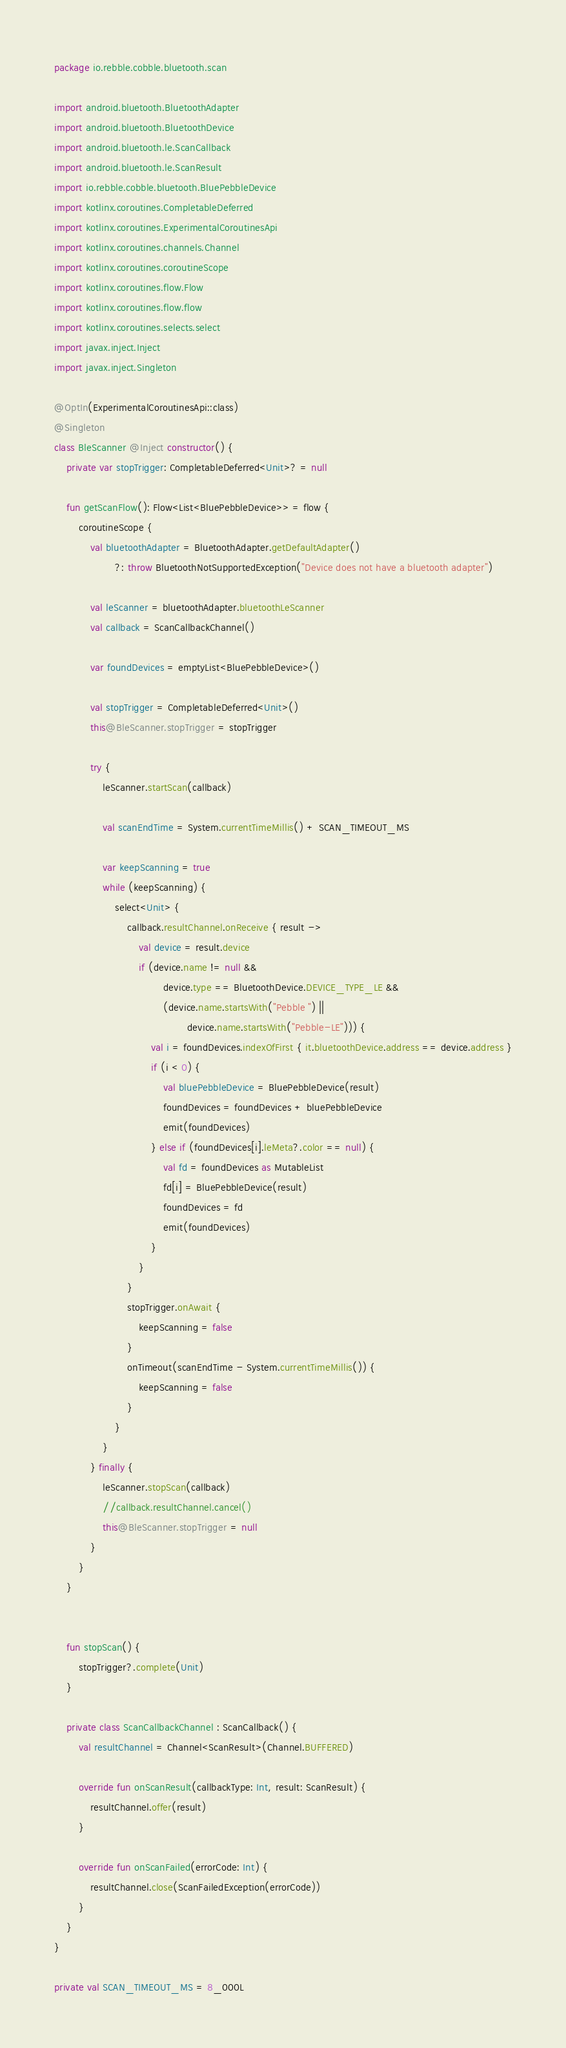Convert code to text. <code><loc_0><loc_0><loc_500><loc_500><_Kotlin_>package io.rebble.cobble.bluetooth.scan

import android.bluetooth.BluetoothAdapter
import android.bluetooth.BluetoothDevice
import android.bluetooth.le.ScanCallback
import android.bluetooth.le.ScanResult
import io.rebble.cobble.bluetooth.BluePebbleDevice
import kotlinx.coroutines.CompletableDeferred
import kotlinx.coroutines.ExperimentalCoroutinesApi
import kotlinx.coroutines.channels.Channel
import kotlinx.coroutines.coroutineScope
import kotlinx.coroutines.flow.Flow
import kotlinx.coroutines.flow.flow
import kotlinx.coroutines.selects.select
import javax.inject.Inject
import javax.inject.Singleton

@OptIn(ExperimentalCoroutinesApi::class)
@Singleton
class BleScanner @Inject constructor() {
    private var stopTrigger: CompletableDeferred<Unit>? = null

    fun getScanFlow(): Flow<List<BluePebbleDevice>> = flow {
        coroutineScope {
            val bluetoothAdapter = BluetoothAdapter.getDefaultAdapter()
                    ?: throw BluetoothNotSupportedException("Device does not have a bluetooth adapter")

            val leScanner = bluetoothAdapter.bluetoothLeScanner
            val callback = ScanCallbackChannel()

            var foundDevices = emptyList<BluePebbleDevice>()

            val stopTrigger = CompletableDeferred<Unit>()
            this@BleScanner.stopTrigger = stopTrigger

            try {
                leScanner.startScan(callback)

                val scanEndTime = System.currentTimeMillis() + SCAN_TIMEOUT_MS

                var keepScanning = true
                while (keepScanning) {
                    select<Unit> {
                        callback.resultChannel.onReceive { result ->
                            val device = result.device
                            if (device.name != null &&
                                    device.type == BluetoothDevice.DEVICE_TYPE_LE &&
                                    (device.name.startsWith("Pebble ") ||
                                            device.name.startsWith("Pebble-LE"))) {
                                val i = foundDevices.indexOfFirst { it.bluetoothDevice.address == device.address }
                                if (i < 0) {
                                    val bluePebbleDevice = BluePebbleDevice(result)
                                    foundDevices = foundDevices + bluePebbleDevice
                                    emit(foundDevices)
                                } else if (foundDevices[i].leMeta?.color == null) {
                                    val fd = foundDevices as MutableList
                                    fd[i] = BluePebbleDevice(result)
                                    foundDevices = fd
                                    emit(foundDevices)
                                }
                            }
                        }
                        stopTrigger.onAwait {
                            keepScanning = false
                        }
                        onTimeout(scanEndTime - System.currentTimeMillis()) {
                            keepScanning = false
                        }
                    }
                }
            } finally {
                leScanner.stopScan(callback)
                //callback.resultChannel.cancel()
                this@BleScanner.stopTrigger = null
            }
        }
    }


    fun stopScan() {
        stopTrigger?.complete(Unit)
    }

    private class ScanCallbackChannel : ScanCallback() {
        val resultChannel = Channel<ScanResult>(Channel.BUFFERED)

        override fun onScanResult(callbackType: Int, result: ScanResult) {
            resultChannel.offer(result)
        }

        override fun onScanFailed(errorCode: Int) {
            resultChannel.close(ScanFailedException(errorCode))
        }
    }
}

private val SCAN_TIMEOUT_MS = 8_000L</code> 